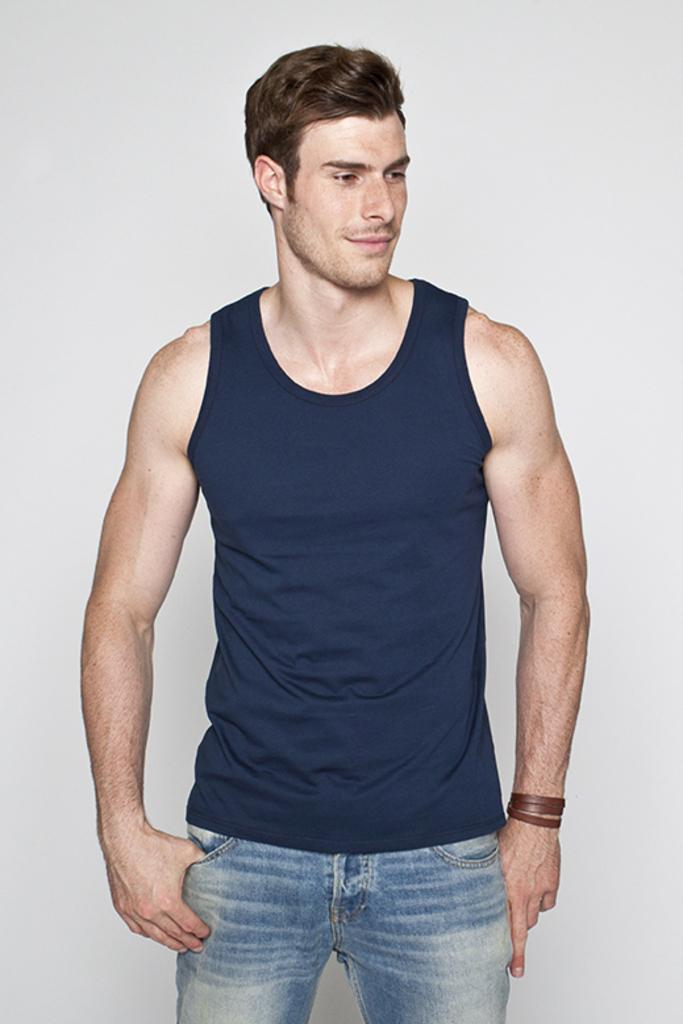What is the main subject of the image? There is a man standing in the center of the image. What type of clothing is the man wearing? The man is wearing jeans. What color is the background of the image? The background of the image is white. Can you tell me how many goldfish are swimming in the background of the image? There are no goldfish present in the image; the background is white. What type of canvas is the man standing on in the image? There is no canvas visible in the image; the man is standing on a surface that is not specified. 